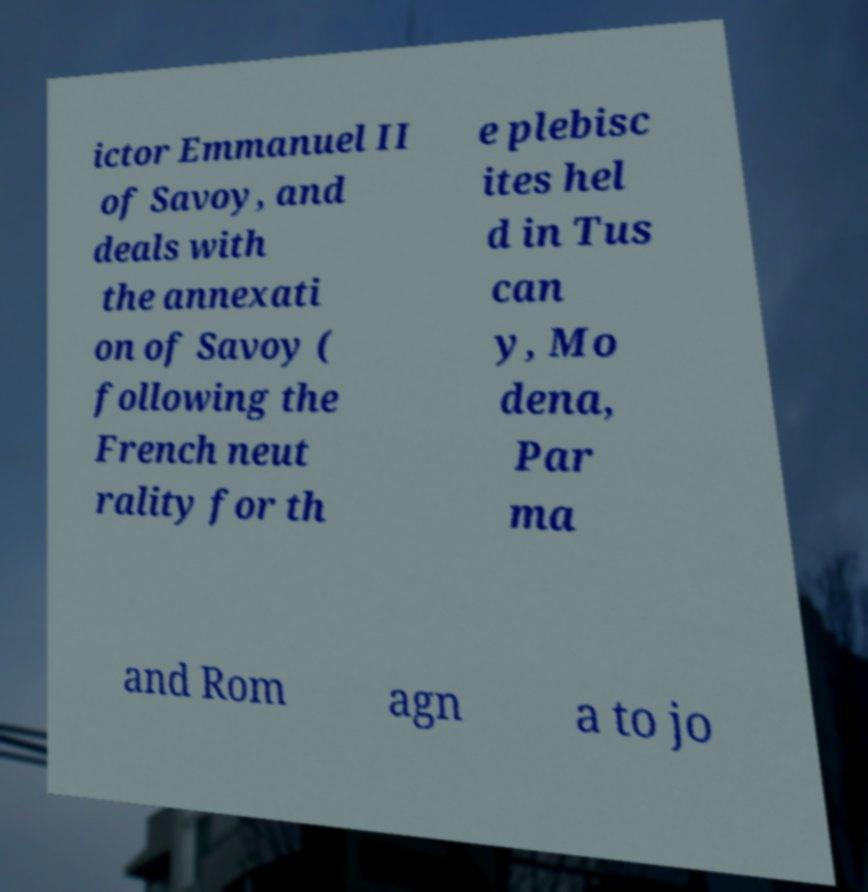Please read and relay the text visible in this image. What does it say? ictor Emmanuel II of Savoy, and deals with the annexati on of Savoy ( following the French neut rality for th e plebisc ites hel d in Tus can y, Mo dena, Par ma and Rom agn a to jo 